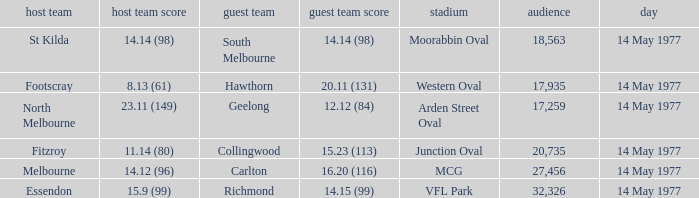Name the away team for essendon Richmond. 